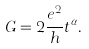<formula> <loc_0><loc_0><loc_500><loc_500>G = 2 \frac { e ^ { 2 } } { h } t ^ { \alpha } .</formula> 